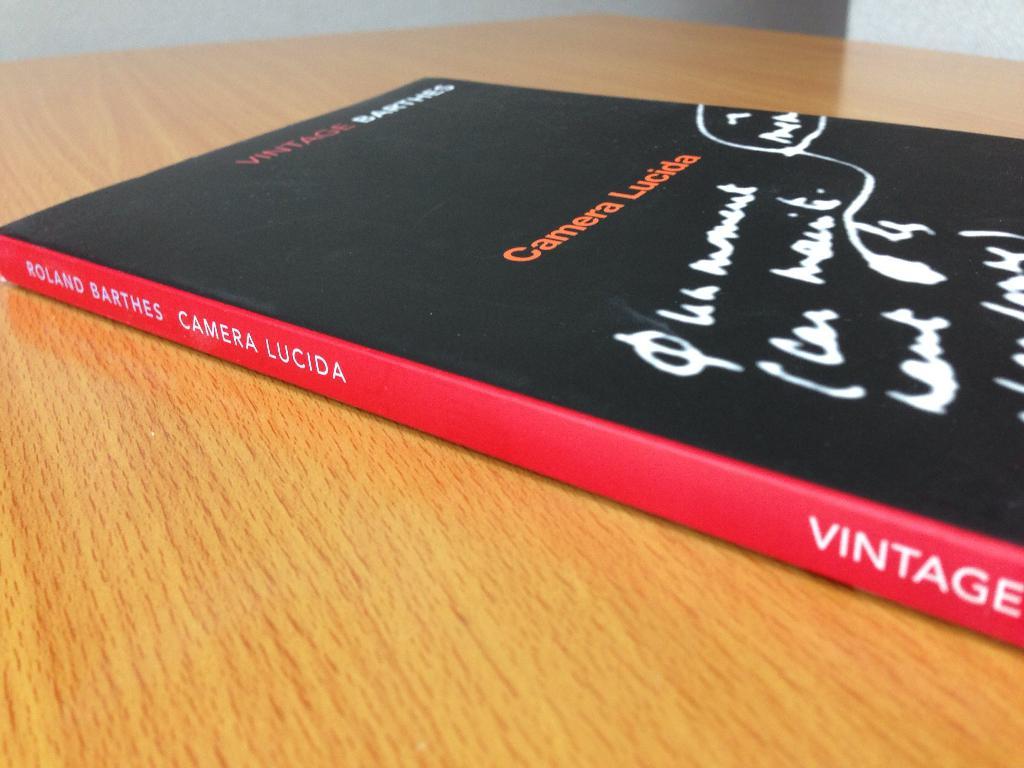What is the title of the book?
Ensure brevity in your answer.  Camera lucida. Who wrote this book?
Your answer should be compact. Roland barthes. 